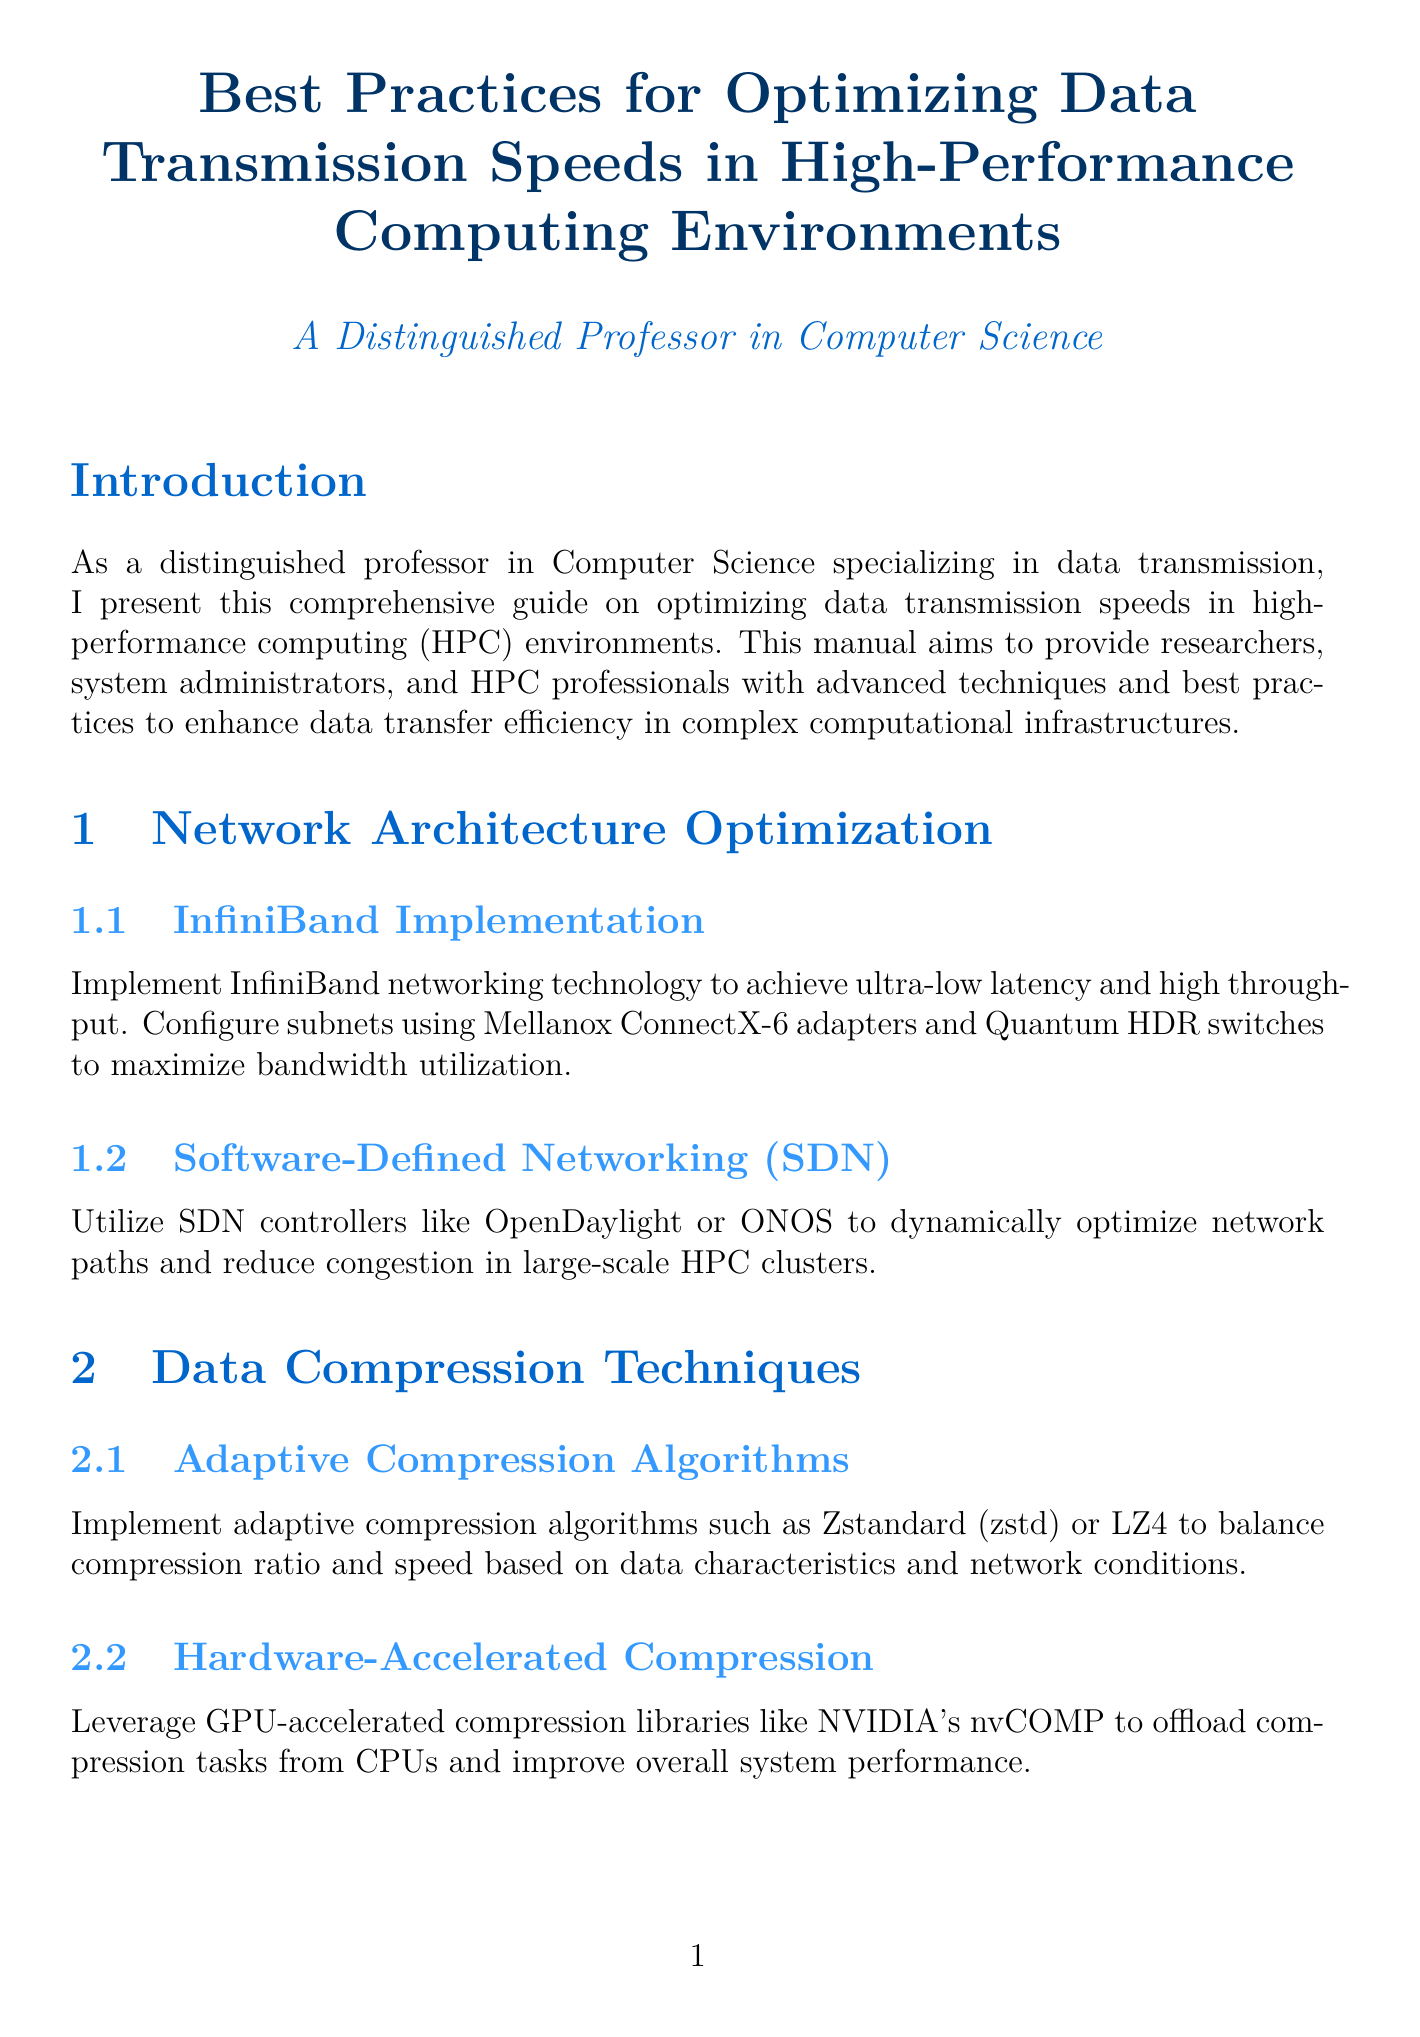What is the title of the manual? The title of the manual is presented at the beginning section, outlining its main focus.
Answer: Best Practices for Optimizing Data Transmission Speeds in High-Performance Computing Environments What technology is recommended for ultra-low latency? The document specifies a networking technology that achieves ultra-low latency and high throughput, found in the Network Architecture Optimization section.
Answer: InfiniBand Which adaptive compression algorithm is mentioned? The document lists a couple of algorithms under Data Compression Techniques, specifically identifying one that adapts based on conditions.
Answer: Zstandard What file system tuning is suggested for HPC environments? The manual suggests adjustments for a specific parallel file system in the relevant section, highlighting the necessary configurations.
Answer: Lustre File System Tuning What protocol is advocated for secure data transfers? The document advises on a specific protocol to ensure secure data transfer, detailed under Data Transfer Protocols.
Answer: Globus GridFTP What does ECMP stand for? The description under Load Balancing and Traffic Management provides the full name of the routing method mentioned.
Answer: Equal-Cost Multi-Path Which tool is deployed for performance monitoring? The document suggests a specific toolkit within the Monitoring and Performance Analysis section to monitor performance end-to-end.
Answer: perfSONAR What encryption standard is mentioned in the security considerations? The manual refers to a specific encryption standard aimed at providing security with low latency, found in the Security Considerations section.
Answer: MACsec What are the advantages of using hardware-accelerated compression? The hardware-accelerated compression section explains its benefits concerning system performance.
Answer: Improve overall system performance 